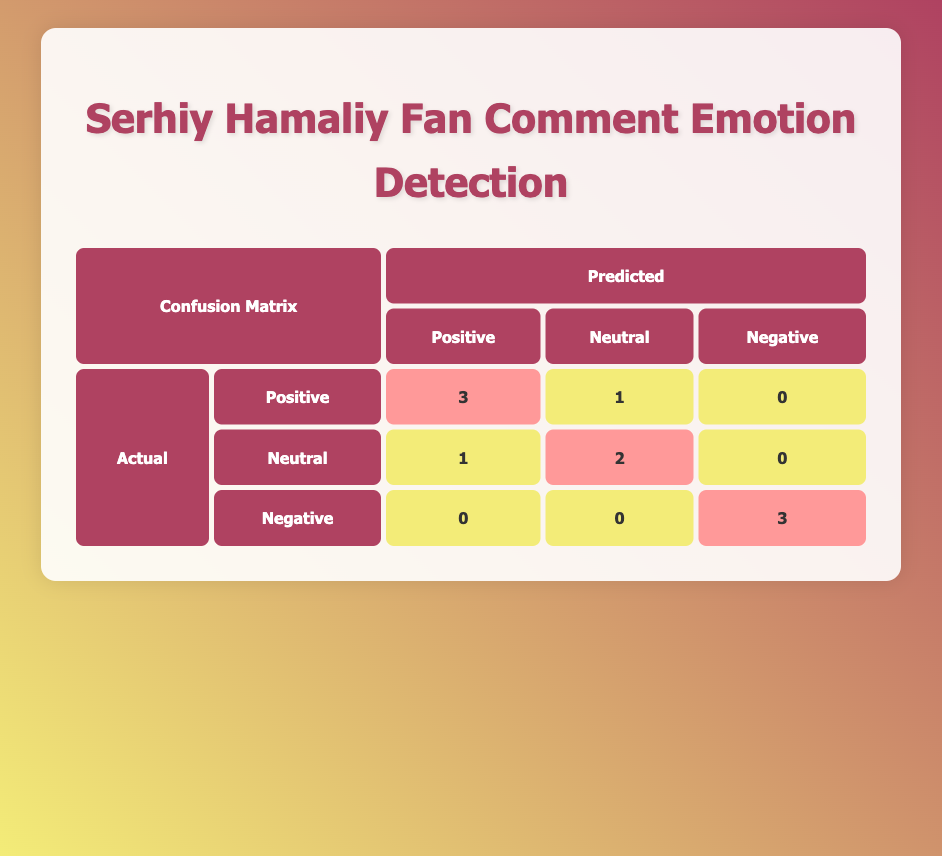What is the number of actual Positive comments that were predicted as Neutral? Looking at the table, the actual Positive comments are represented in the first row. Under the Neutral column, the value is 1, which indicates that one actual Positive comment was predicted as Neutral.
Answer: 1 How many comments were predicted as Negative? To find the total number of comments predicted as Negative, we can sum the values in the Negative column, which includes 0 (from Positive), 0 (from Neutral), and 3 (from Negative). Adding these up gives us 0 + 0 + 3 = 3 predictions as Negative.
Answer: 3 What is the sum of actual Neutral comments predicted as Positive and Negative? Checking the actual Neutral, the number of comments predicted as Positive is 1, and the number of comments predicted as Negative is 0. The sum is 1 + 0 = 1.
Answer: 1 Is it true that all Negative comments were predicted correctly? We can verify this by checking the row for actual Negative comments. The predicted values show 0 as Positive, 0 as Neutral, and 3 as Negative, indicating that all Negative comments were predicted correctly.
Answer: Yes What percentage of actual Positive comments were predicted as Positive? There are 3 actual Positive comments, and 3 of them were predicted as Positive as per the table. To find the percentage, we use the formula (3/3) * 100 = 100%.
Answer: 100% What is the difference between the number of actual Neutral comments and the number predicted as Neutral? The actual Neutral comments total 3 (in the second row), and the predicted Neutral comments total 2 (from the second row). The difference is 3 - 2 = 1.
Answer: 1 How many actual Positive comments were incorrectly predicted? From the actual Positive row, 3 comments were predicted as Positive and 1 as Neutral, which means that 1 actual Positive comment was incorrectly predicted as Neutral. Therefore, the answer is 1.
Answer: 1 What emotion was predicted the least among the comments? By looking at the table, we can see the predicted values for each emotion (Positive: 5, Neutral: 3, Negative: 3). Since Neutral and Negative both have 3 predictions, they are tied for being predicted the least.
Answer: Neutral and Negative How many total comments were analyzed? We can find the total by counting the entries in the actual_labels array, which contains 10 comments in total (10 entries).
Answer: 10 